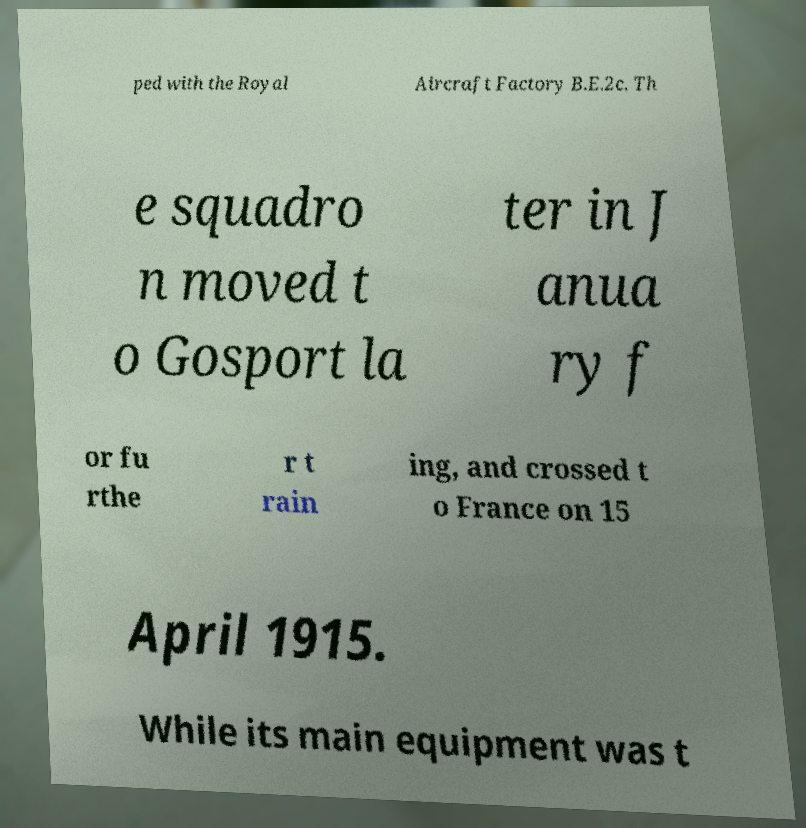For documentation purposes, I need the text within this image transcribed. Could you provide that? ped with the Royal Aircraft Factory B.E.2c. Th e squadro n moved t o Gosport la ter in J anua ry f or fu rthe r t rain ing, and crossed t o France on 15 April 1915. While its main equipment was t 